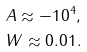Convert formula to latex. <formula><loc_0><loc_0><loc_500><loc_500>A \approx - 1 0 ^ { 4 } , \\ W \approx 0 . 0 1 .</formula> 